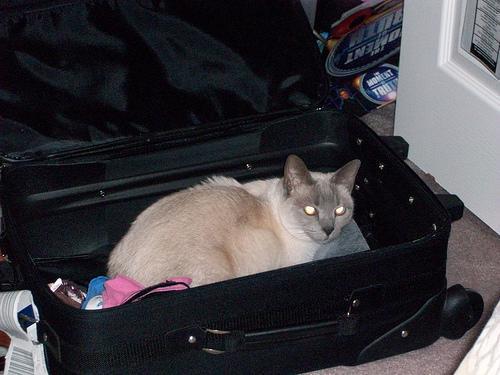How many cats are in the suitcase?
Give a very brief answer. 1. How many suitcases are in the photo?
Give a very brief answer. 1. 